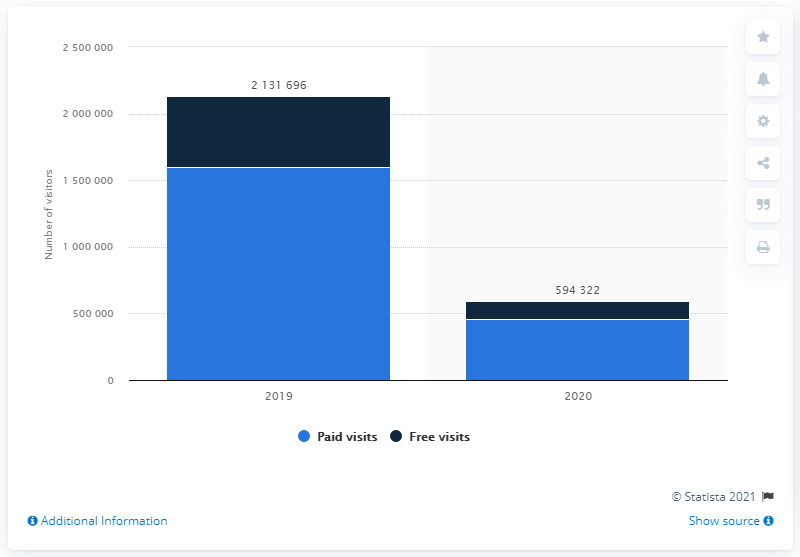Highlight a few significant elements in this photo. In 2020, the Uffizi Gallery was visited by 455,960 tourists. 